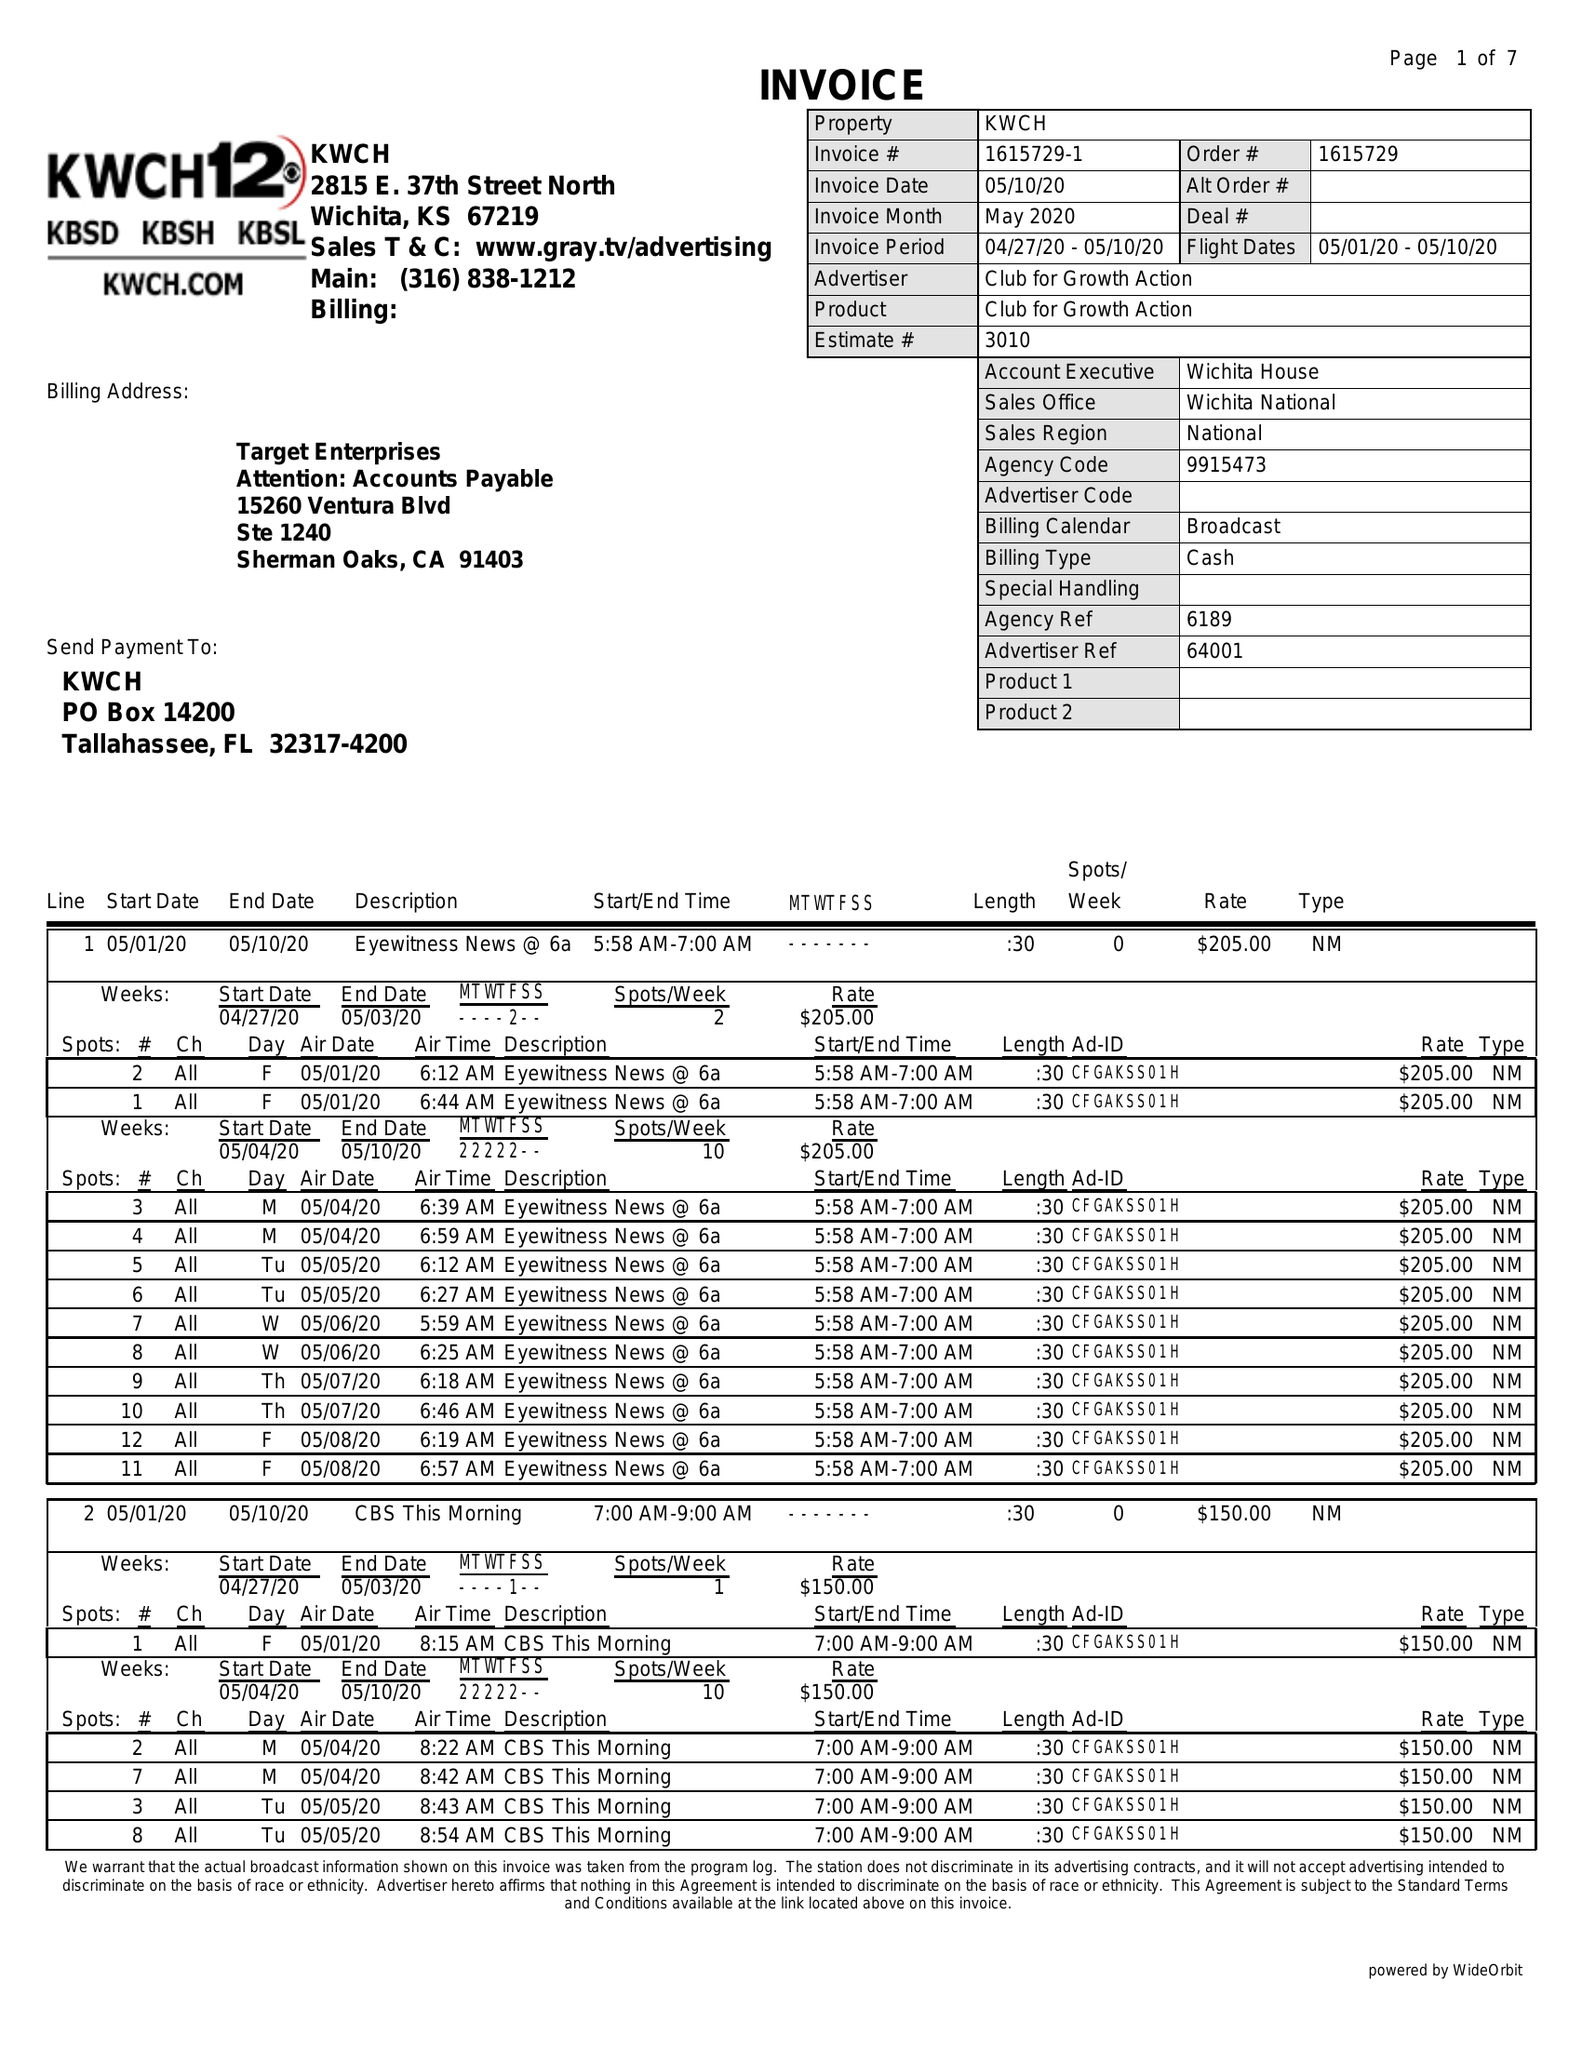What is the value for the flight_to?
Answer the question using a single word or phrase. 05/10/20 